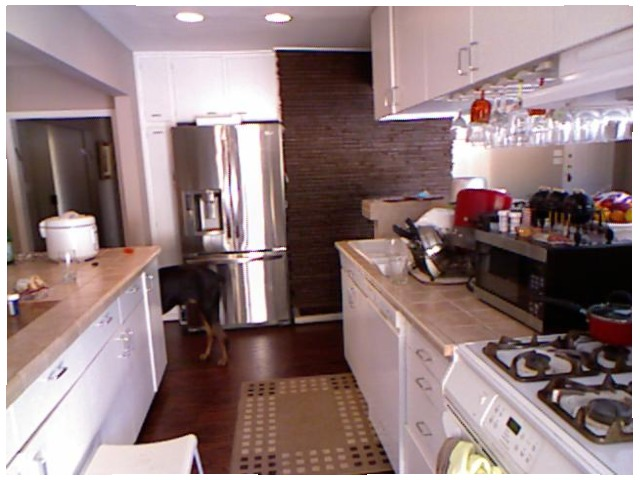<image>
Can you confirm if the table is under the micro oven? Yes. The table is positioned underneath the micro oven, with the micro oven above it in the vertical space. 